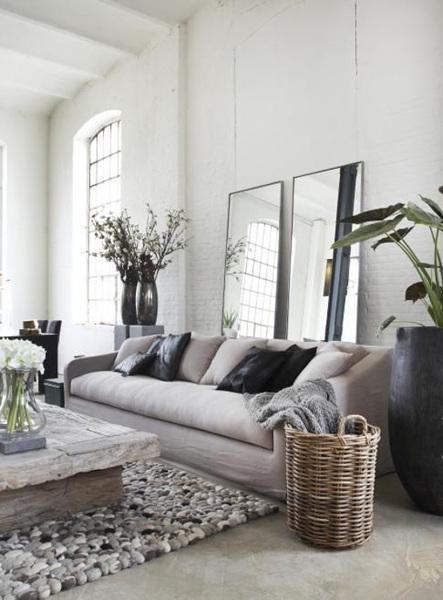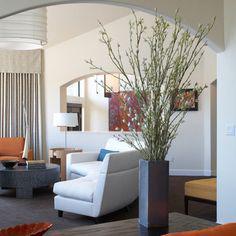The first image is the image on the left, the second image is the image on the right. Considering the images on both sides, is "Each image includes at least one vase that holds branches that extend upward instead of drooping leaves and includes at least one vase that sits on the floor." valid? Answer yes or no. Yes. The first image is the image on the left, the second image is the image on the right. Examine the images to the left and right. Is the description "There are empty vases on a shelf in the image on the left." accurate? Answer yes or no. No. 